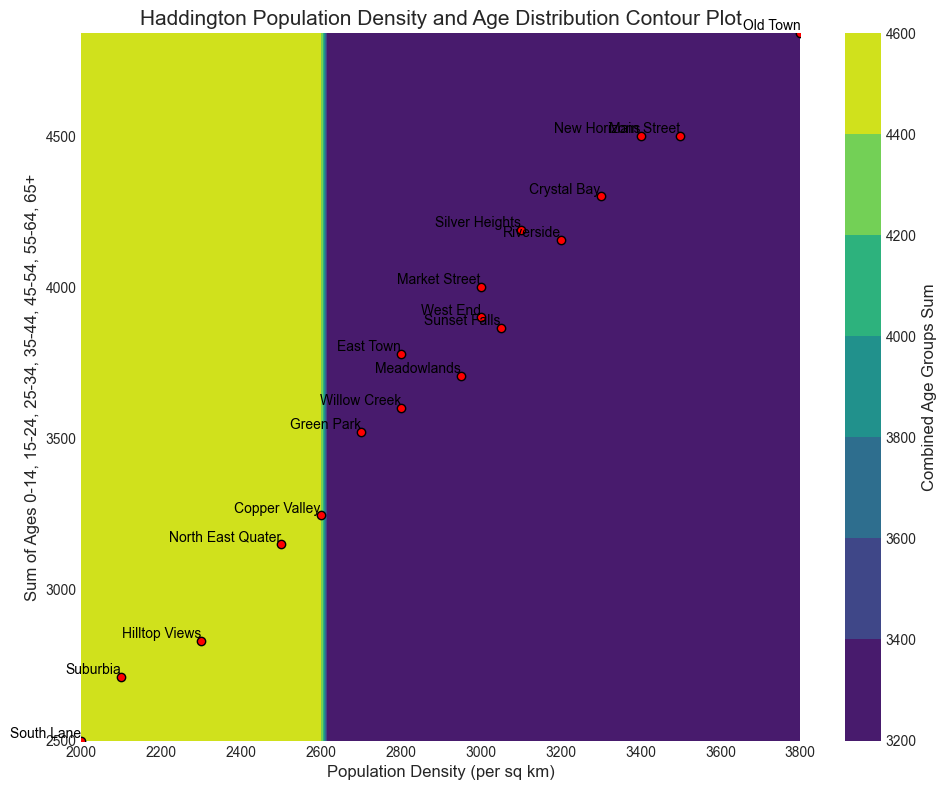Which neighborhood has the highest population density? By observing the marked points on the x-axis, Old Town has the furthest right point indicating it has the highest population density.
Answer: Old Town Which neighborhoods have a combined age group total between 3000 and 3500? The y-axis represents the combined age group total. By identifying points within this range and checking the labels, neighborhoods falling in this range are Main Street, Old Town, New Horizons, Riverside, and Silver Heights.
Answer: Main Street, Old Town, New Horizons, Riverside, Silver Heights What is the difference in combined age group totals between Main Street and Suburbia? Main Street has a combined age group total around 4500, while Suburbia has about 2980. Subtract the latter from the former to get the difference (4500 - 2980).
Answer: 1520 Which neighborhoods fall within a population density range of 2500 to 3000 and a combined age group total below 3500? Look for neighborhoods within the x-range 2500-3000 and y-range below 3500. The neighborhoods meeting these criteria are Green Park, Market Street, West End, East Town, and possibly Copper Valley and Meadowlands.
Answer: Green Park, Market Street, West End, East Town, Copper Valley, Meadowlands Which neighborhood is marked with the darkest color on the contour plot? Darker colors typically indicate higher combined age group totals. Looking at the darkest area with labeled points, Old Town falls within that darkened region.
Answer: Old Town What is the combined age group total for Hilltop Views? Identify the scatter point for Hilltop Views and read the approximate y-axis value, which is around 2840.
Answer: 2840 Compare the population density and age group totals of Riverside and Sunset Falls. Which one is higher in each category? Locate both neighborhoods on the plot and compare x-axis (population density) and y-axis (age group totals). Riverside has higher population density and higher age group totals compared to Sunset Falls.
Answer: Riverside is higher in both categories What is the average population density of Main Street, Market Street, and North East Quater? Add the population densities of these neighborhoods and divide by the number of neighborhoods: (3500 + 3000 + 2500)/3.
Answer: 3000 Which neighborhood has the lowest combined age group total and what is its population density? Find the neighborhood with the lowest y-axis value. South Lane appears to have the lowest combined age group total. The corresponding x-axis value for South Lane is around 2000 population density.
Answer: South Lane, 2000 Is there a neighborhood with a combined age group total around 3200? If so, name one and provide its population density. Locate points on the plot that intersect with y-axis value around 3200. One such point is West End, which has a population density of 3000.
Answer: West End, 3000 